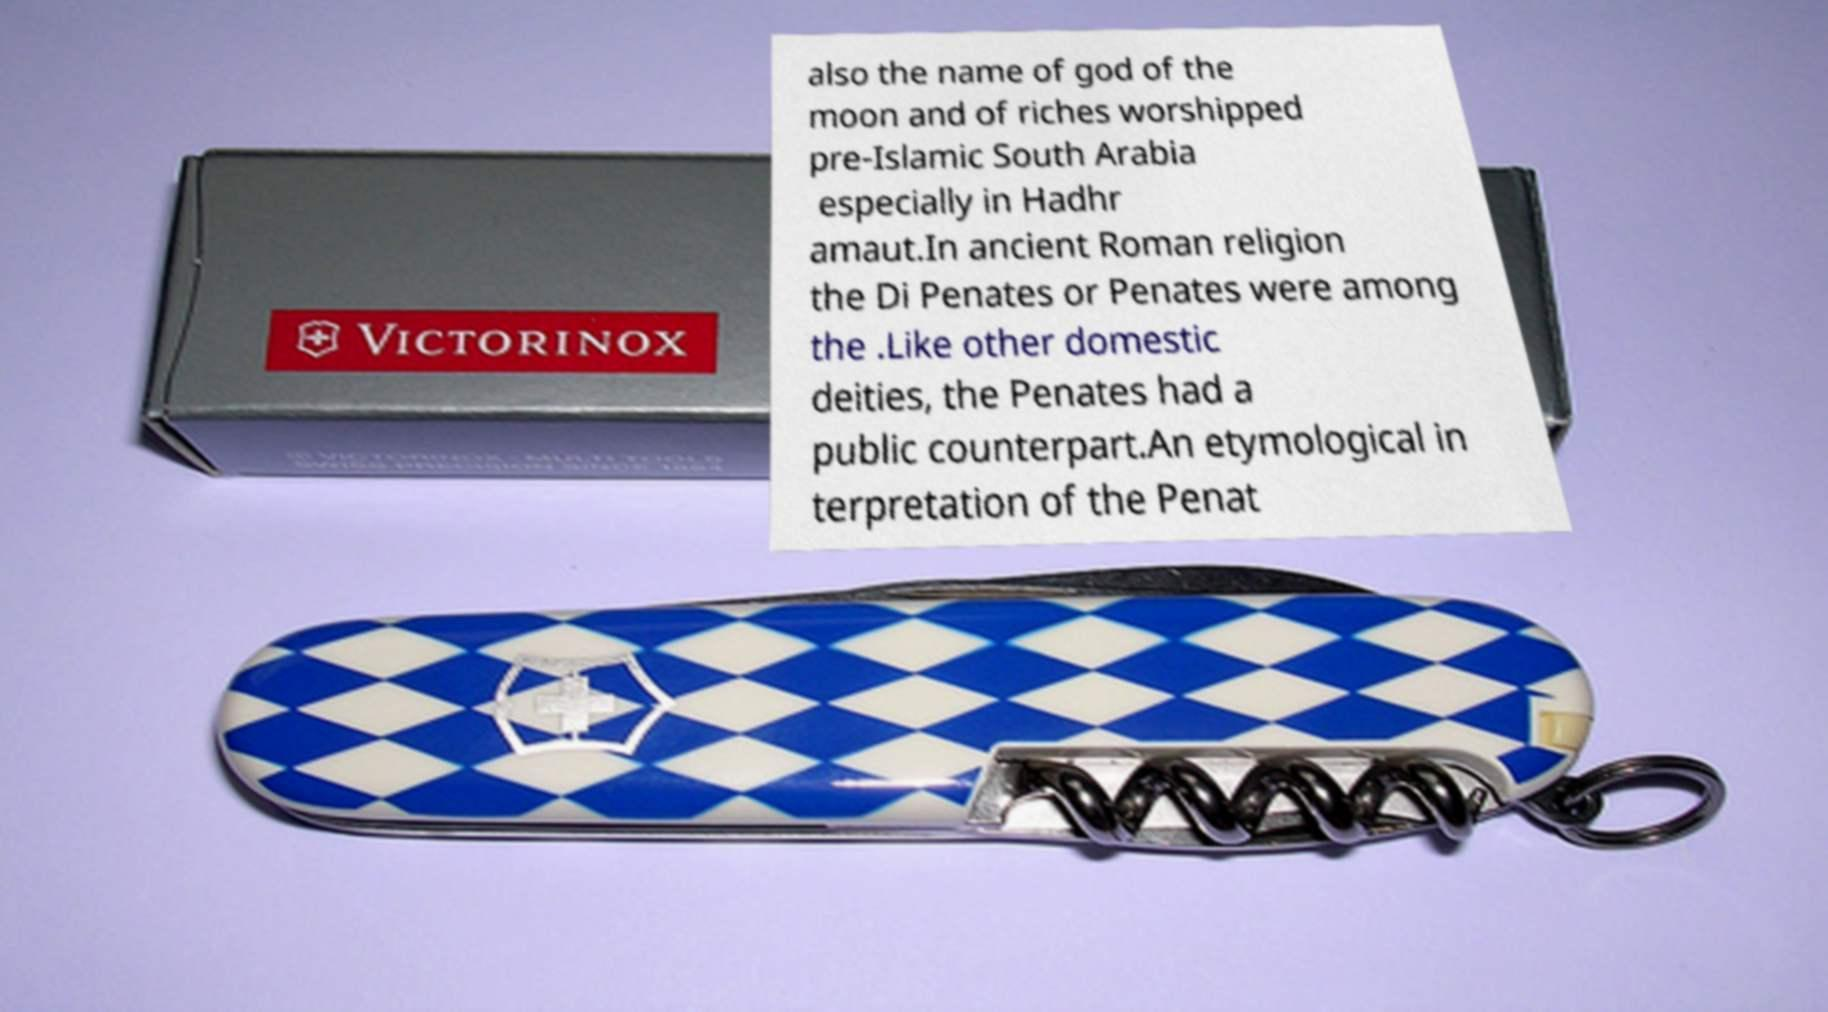For documentation purposes, I need the text within this image transcribed. Could you provide that? also the name of god of the moon and of riches worshipped pre-Islamic South Arabia especially in Hadhr amaut.In ancient Roman religion the Di Penates or Penates were among the .Like other domestic deities, the Penates had a public counterpart.An etymological in terpretation of the Penat 